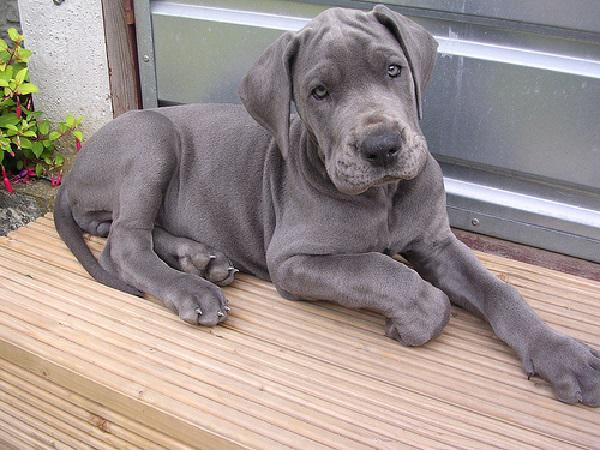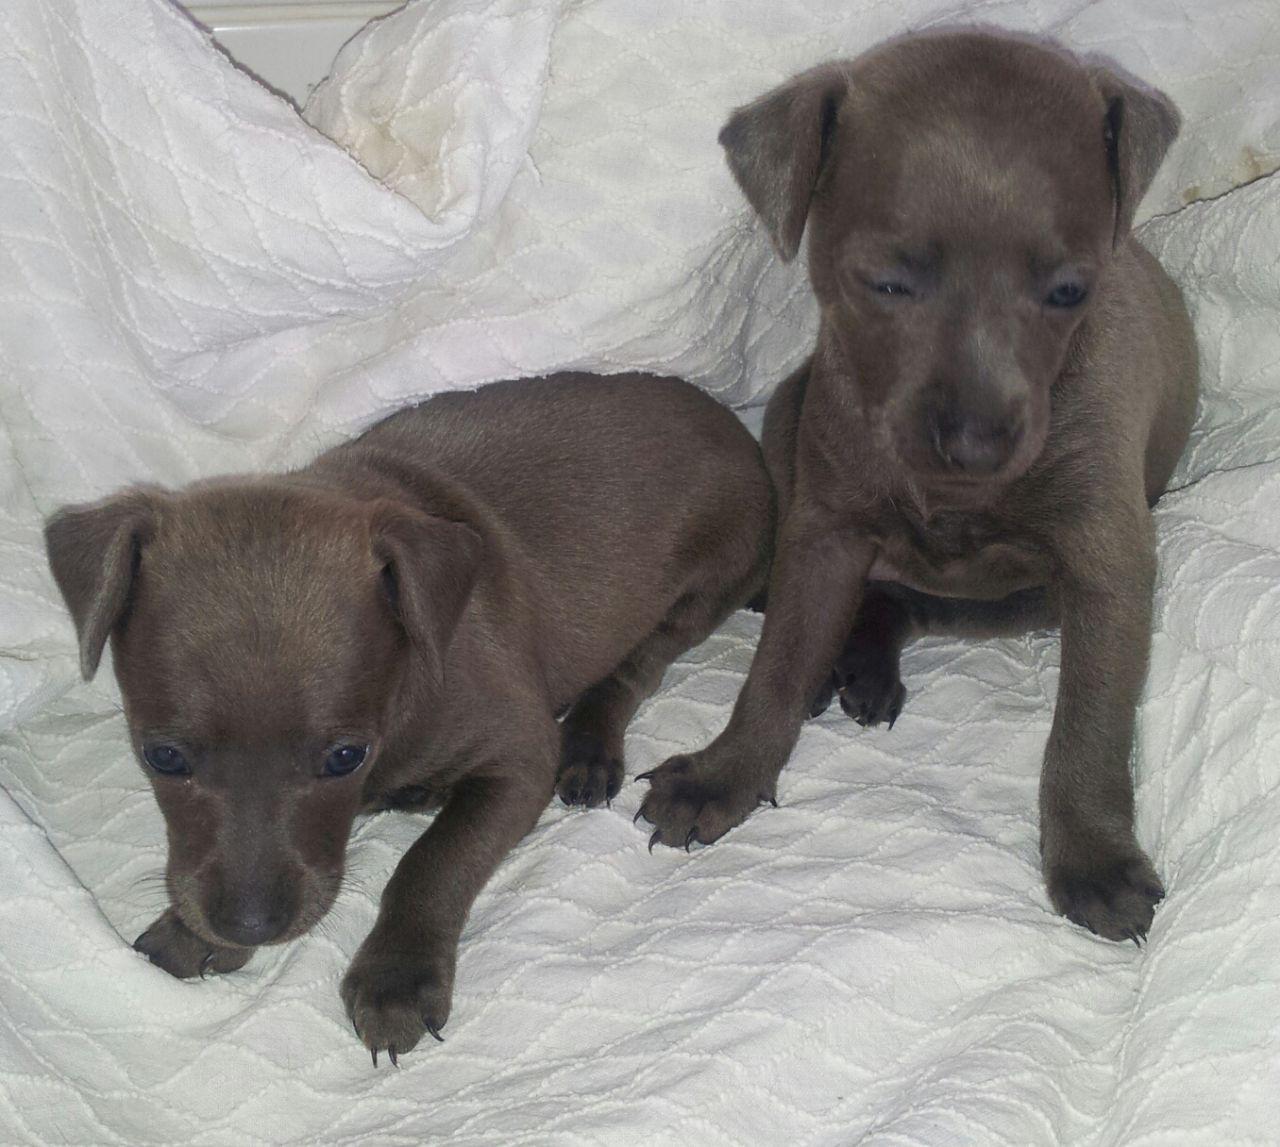The first image is the image on the left, the second image is the image on the right. Given the left and right images, does the statement "Two dogs pose together in one of the pictures." hold true? Answer yes or no. Yes. The first image is the image on the left, the second image is the image on the right. For the images shown, is this caption "An image contains two solid-colored hound dogs." true? Answer yes or no. Yes. 